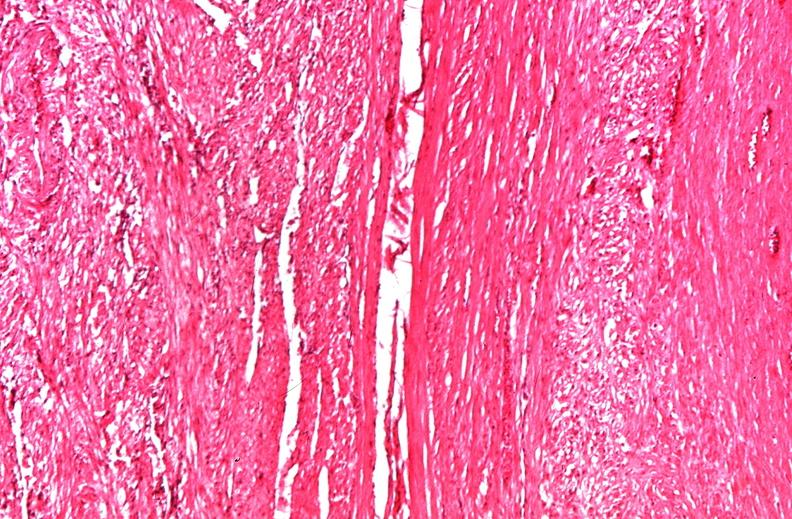s female reproductive present?
Answer the question using a single word or phrase. Yes 